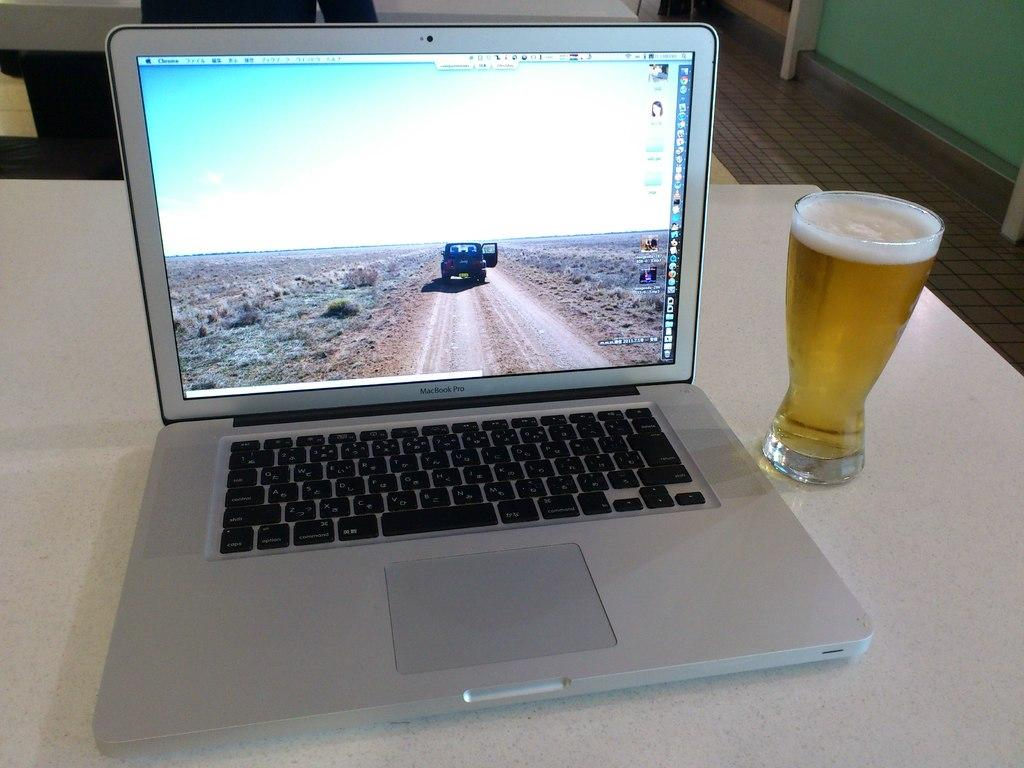What type of table is in the image? There is a white table in the image. What electronic device is on the table? A laptop is present on the table. What type of glassware is in the image? There is a wine glass in the image. What can be seen in the background of the image? There is a wall and the floor visible in the background of the image. What type of science experiment is being conducted with the potato in the image? There is no potato present in the image, and therefore no science experiment can be observed. 